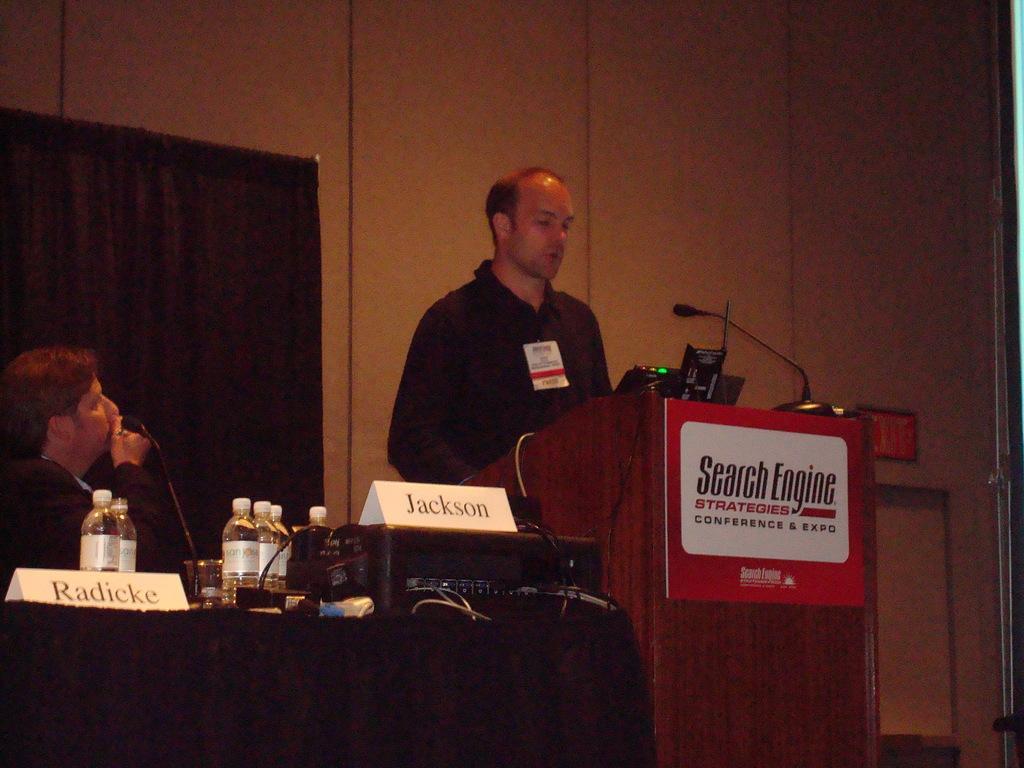Can you describe this image briefly? In the right side a man is standing near the podium and in the left side a man is sitting. 